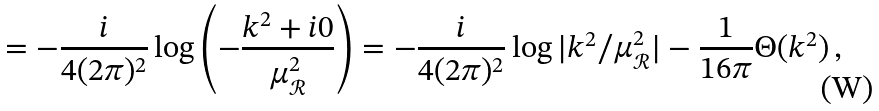Convert formula to latex. <formula><loc_0><loc_0><loc_500><loc_500>= - \frac { i } { 4 ( 2 \pi ) ^ { 2 } } \log \left ( - \frac { k ^ { 2 } + i 0 } { \mu _ { \mathcal { R } } ^ { 2 } } \right ) = - \frac { i } { 4 ( 2 \pi ) ^ { 2 } } \log | k ^ { 2 } / \mu _ { \mathcal { R } } ^ { 2 } | - \frac { 1 } { 1 6 \pi } \Theta ( k ^ { 2 } ) \, ,</formula> 